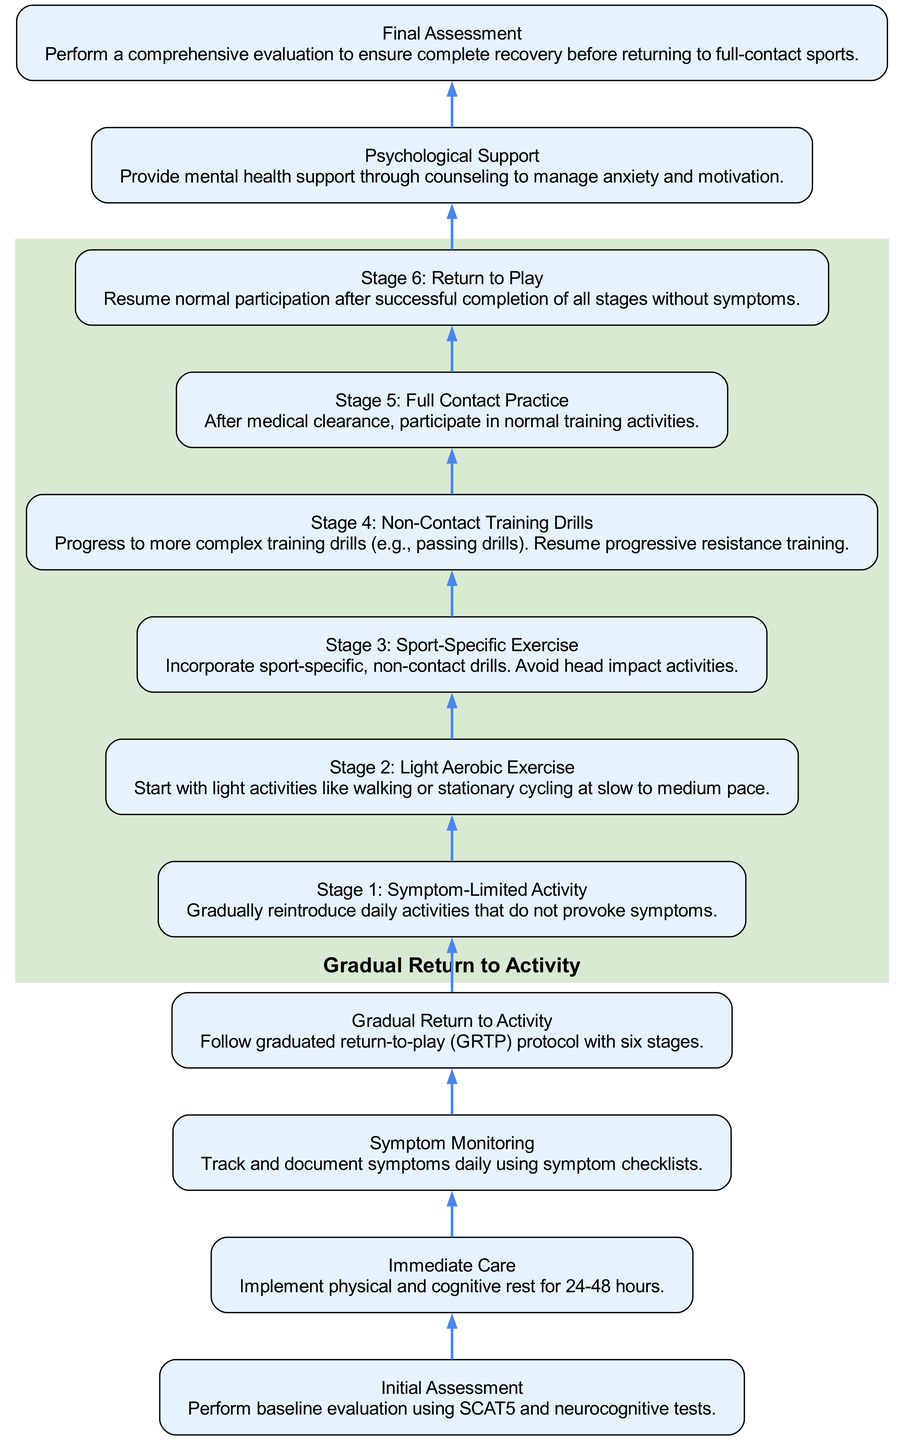What is the first step in the rehabilitation process? The diagram indicates that the first step in the rehabilitation process is "Initial Assessment." This is the bottommost node in the flowchart, serving as the starting point.
Answer: Initial Assessment How many stages are in the Gradual Return to Activity protocol? The diagram shows six stages in the Gradual Return to Activity protocol, which are clearly labeled from Stage 1 to Stage 6.
Answer: Six stages What is the focus during Stage 2? The diagram specifies that Stage 2 involves "Light Aerobic Exercise." This is a distinct description attached to that stage, indicating the type of activities to engage in during this phase.
Answer: Light Aerobic Exercise Which step comes immediately after Immediate Care? According to the flowchart, "Symptom Monitoring" follows the "Immediate Care." We can track the connection by moving from the Immediate Care node up to the next node.
Answer: Symptom Monitoring What is the main purpose of Psychological Support in the process? The diagram notes that the purpose of Psychological Support is to provide "mental health support through counseling to manage anxiety and motivation." This highlights its intent within the overall process flow.
Answer: Mental health support After completing all stages without symptoms, what is the next step? The diagram indicates that after successful completion of all stages without symptoms, the next step is "Return to Play." This is the final node linking the process back to normal activity.
Answer: Return to Play How many activities are included in the Gradual Return to Activity section? The Gradual Return to Activity section contains six activities, starting from "Stage 1: Symptom-Limited Activity" up to "Stage 6: Return to Play." Counting these stages gives us the total number of activities.
Answer: Six activities What is performed at the Final Assessment? The diagram states that a "comprehensive evaluation" is performed at the Final Assessment to ensure complete recovery before engaging in full-contact sports. This describes the examination's nature at this stage.
Answer: Comprehensive evaluation At what stage is non-contact training introduced? The flowchart shows that "Stage 4: Non-Contact Training Drills" is where non-contact training activities are introduced. This stage is explicitly labeled in the diagram.
Answer: Stage 4 